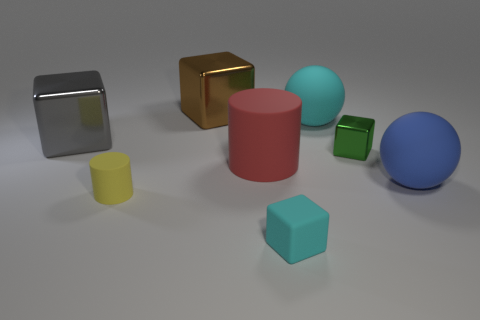Subtract all matte cubes. How many cubes are left? 3 Add 2 rubber objects. How many objects exist? 10 Subtract all brown blocks. How many blocks are left? 3 Subtract 3 blocks. How many blocks are left? 1 Subtract all cylinders. How many objects are left? 6 Subtract all purple balls. Subtract all blue cubes. How many balls are left? 2 Subtract all red cylinders. How many gray spheres are left? 0 Subtract all large brown metallic cubes. Subtract all big metallic blocks. How many objects are left? 5 Add 6 brown things. How many brown things are left? 7 Add 3 big metal blocks. How many big metal blocks exist? 5 